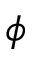Convert formula to latex. <formula><loc_0><loc_0><loc_500><loc_500>\phi</formula> 